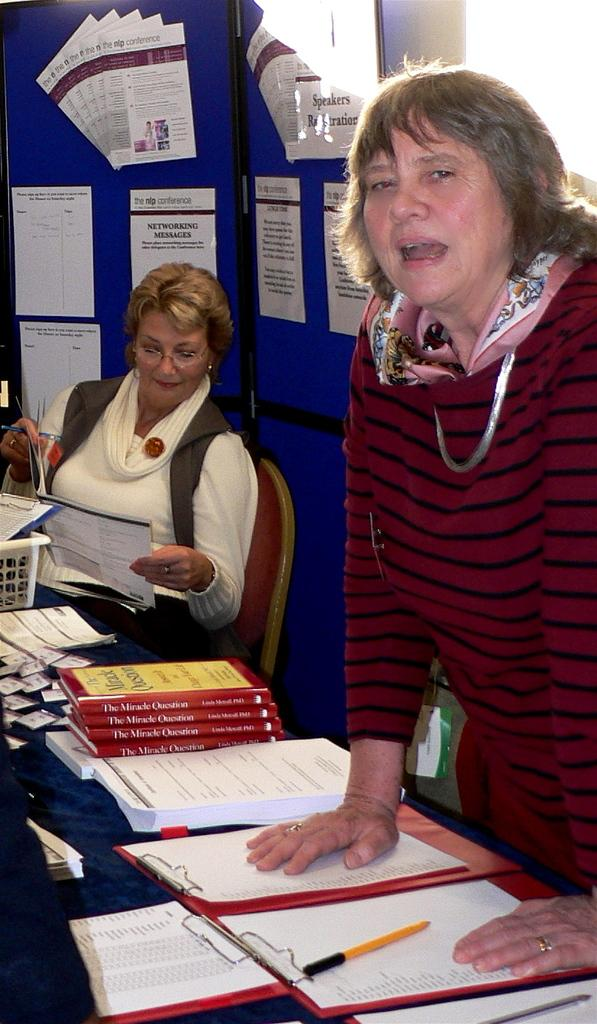<image>
Describe the image concisely. Two women sit in front of a display about The Miracle Question 